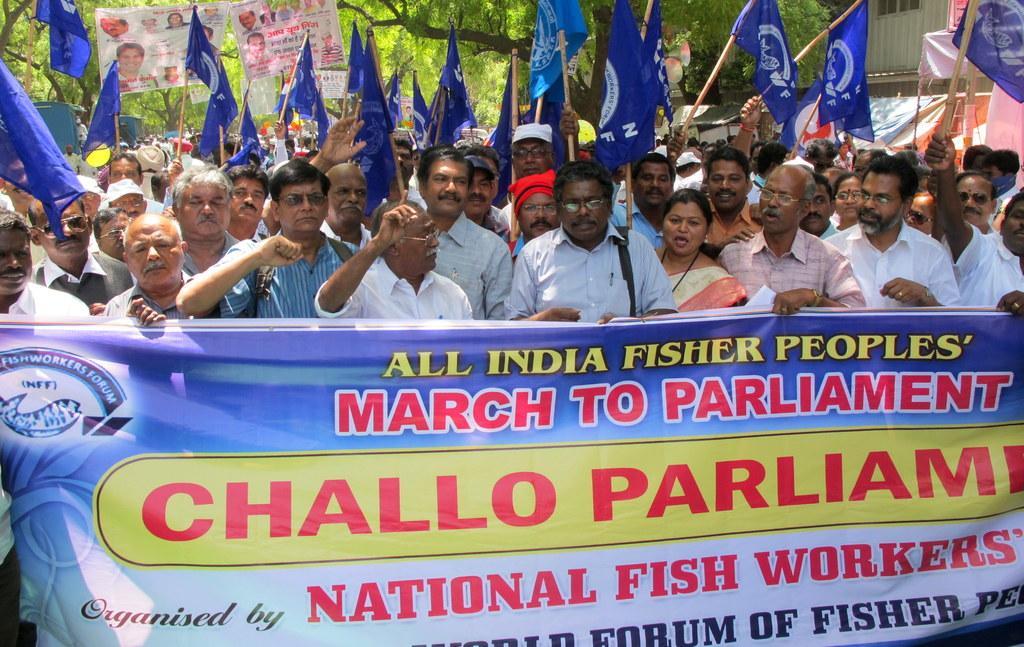In one or two sentences, can you explain what this image depicts? There are many people holding flags. In front of them there is a banner with something written on that. In the background there are trees. Some people are holding placards. 